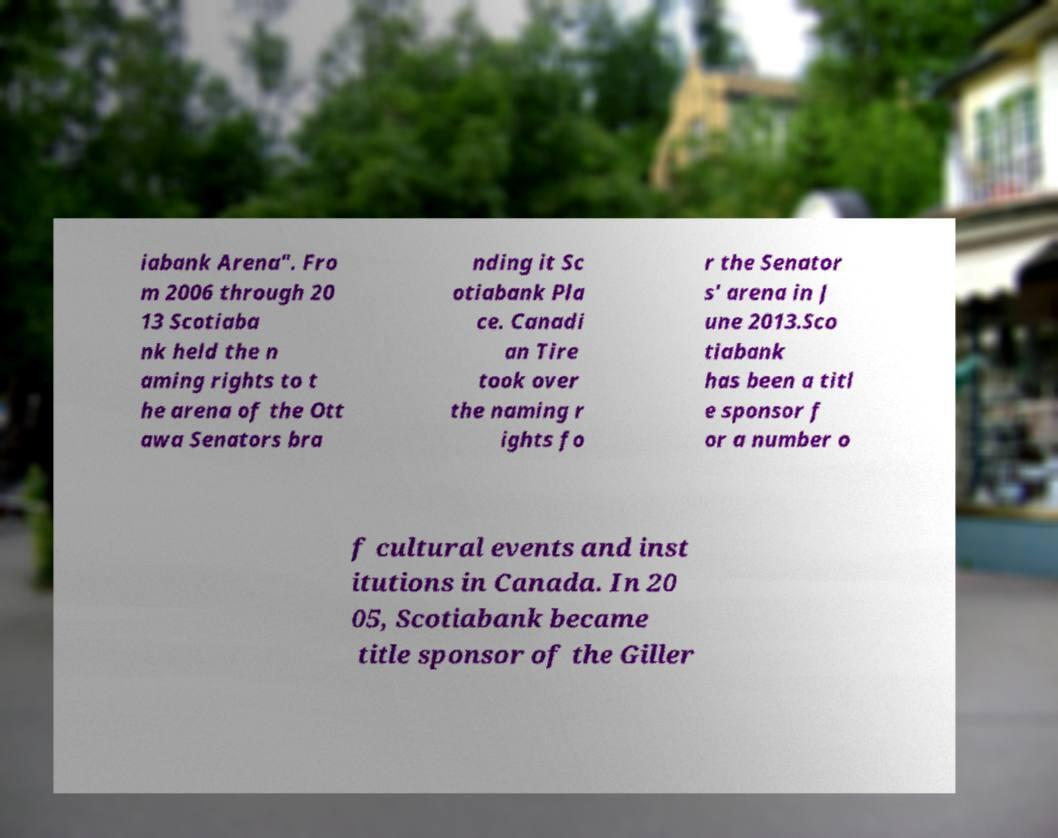What messages or text are displayed in this image? I need them in a readable, typed format. iabank Arena". Fro m 2006 through 20 13 Scotiaba nk held the n aming rights to t he arena of the Ott awa Senators bra nding it Sc otiabank Pla ce. Canadi an Tire took over the naming r ights fo r the Senator s' arena in J une 2013.Sco tiabank has been a titl e sponsor f or a number o f cultural events and inst itutions in Canada. In 20 05, Scotiabank became title sponsor of the Giller 